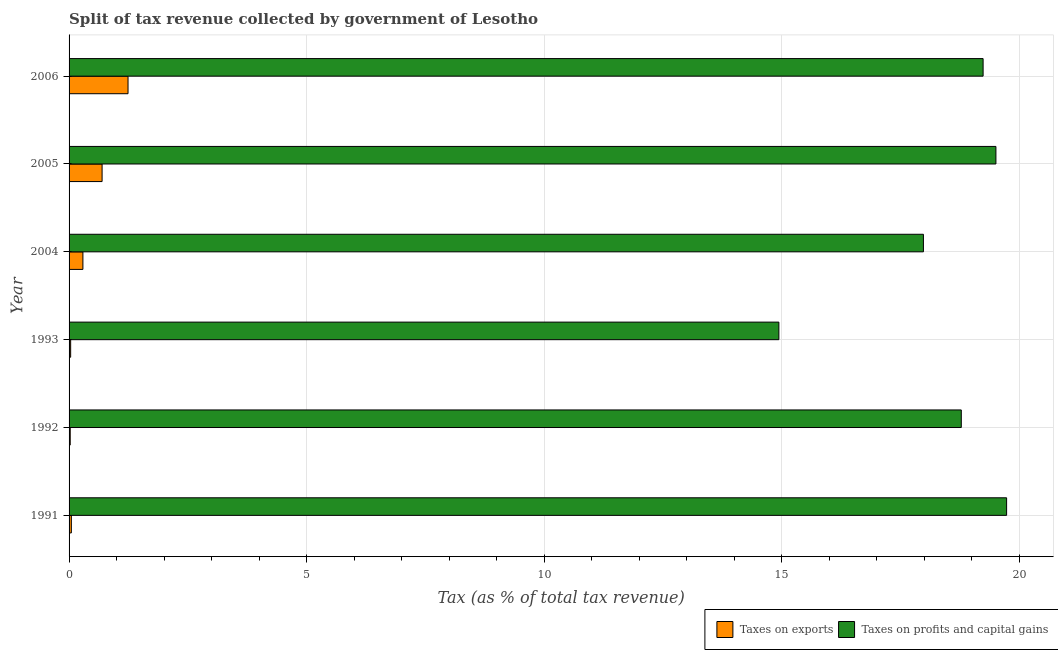How many groups of bars are there?
Make the answer very short. 6. How many bars are there on the 2nd tick from the top?
Offer a very short reply. 2. How many bars are there on the 2nd tick from the bottom?
Make the answer very short. 2. What is the label of the 4th group of bars from the top?
Provide a short and direct response. 1993. What is the percentage of revenue obtained from taxes on exports in 1991?
Give a very brief answer. 0.05. Across all years, what is the maximum percentage of revenue obtained from taxes on exports?
Ensure brevity in your answer.  1.24. Across all years, what is the minimum percentage of revenue obtained from taxes on exports?
Provide a succinct answer. 0.02. In which year was the percentage of revenue obtained from taxes on exports maximum?
Keep it short and to the point. 2006. In which year was the percentage of revenue obtained from taxes on profits and capital gains minimum?
Your answer should be very brief. 1993. What is the total percentage of revenue obtained from taxes on profits and capital gains in the graph?
Your response must be concise. 110.2. What is the difference between the percentage of revenue obtained from taxes on profits and capital gains in 1991 and that in 2005?
Provide a short and direct response. 0.23. What is the difference between the percentage of revenue obtained from taxes on exports in 2006 and the percentage of revenue obtained from taxes on profits and capital gains in 2005?
Make the answer very short. -18.27. What is the average percentage of revenue obtained from taxes on exports per year?
Offer a terse response. 0.39. In the year 2004, what is the difference between the percentage of revenue obtained from taxes on profits and capital gains and percentage of revenue obtained from taxes on exports?
Offer a terse response. 17.69. In how many years, is the percentage of revenue obtained from taxes on profits and capital gains greater than 11 %?
Your answer should be very brief. 6. What is the ratio of the percentage of revenue obtained from taxes on exports in 1993 to that in 2006?
Give a very brief answer. 0.03. Is the difference between the percentage of revenue obtained from taxes on profits and capital gains in 2005 and 2006 greater than the difference between the percentage of revenue obtained from taxes on exports in 2005 and 2006?
Offer a very short reply. Yes. What is the difference between the highest and the second highest percentage of revenue obtained from taxes on exports?
Ensure brevity in your answer.  0.55. What is the difference between the highest and the lowest percentage of revenue obtained from taxes on exports?
Offer a very short reply. 1.22. In how many years, is the percentage of revenue obtained from taxes on profits and capital gains greater than the average percentage of revenue obtained from taxes on profits and capital gains taken over all years?
Your answer should be compact. 4. What does the 2nd bar from the top in 1993 represents?
Provide a short and direct response. Taxes on exports. What does the 1st bar from the bottom in 1993 represents?
Your answer should be compact. Taxes on exports. How many years are there in the graph?
Keep it short and to the point. 6. Are the values on the major ticks of X-axis written in scientific E-notation?
Give a very brief answer. No. Does the graph contain grids?
Offer a very short reply. Yes. Where does the legend appear in the graph?
Offer a terse response. Bottom right. How many legend labels are there?
Provide a short and direct response. 2. How are the legend labels stacked?
Offer a very short reply. Horizontal. What is the title of the graph?
Provide a short and direct response. Split of tax revenue collected by government of Lesotho. What is the label or title of the X-axis?
Provide a succinct answer. Tax (as % of total tax revenue). What is the Tax (as % of total tax revenue) in Taxes on exports in 1991?
Offer a terse response. 0.05. What is the Tax (as % of total tax revenue) of Taxes on profits and capital gains in 1991?
Offer a terse response. 19.74. What is the Tax (as % of total tax revenue) in Taxes on exports in 1992?
Keep it short and to the point. 0.02. What is the Tax (as % of total tax revenue) in Taxes on profits and capital gains in 1992?
Your answer should be compact. 18.78. What is the Tax (as % of total tax revenue) of Taxes on exports in 1993?
Offer a very short reply. 0.03. What is the Tax (as % of total tax revenue) of Taxes on profits and capital gains in 1993?
Keep it short and to the point. 14.94. What is the Tax (as % of total tax revenue) of Taxes on exports in 2004?
Your response must be concise. 0.29. What is the Tax (as % of total tax revenue) in Taxes on profits and capital gains in 2004?
Give a very brief answer. 17.99. What is the Tax (as % of total tax revenue) of Taxes on exports in 2005?
Your response must be concise. 0.7. What is the Tax (as % of total tax revenue) of Taxes on profits and capital gains in 2005?
Your answer should be compact. 19.51. What is the Tax (as % of total tax revenue) in Taxes on exports in 2006?
Your response must be concise. 1.24. What is the Tax (as % of total tax revenue) of Taxes on profits and capital gains in 2006?
Offer a terse response. 19.24. Across all years, what is the maximum Tax (as % of total tax revenue) in Taxes on exports?
Offer a very short reply. 1.24. Across all years, what is the maximum Tax (as % of total tax revenue) in Taxes on profits and capital gains?
Offer a terse response. 19.74. Across all years, what is the minimum Tax (as % of total tax revenue) in Taxes on exports?
Your answer should be compact. 0.02. Across all years, what is the minimum Tax (as % of total tax revenue) of Taxes on profits and capital gains?
Give a very brief answer. 14.94. What is the total Tax (as % of total tax revenue) of Taxes on exports in the graph?
Offer a terse response. 2.33. What is the total Tax (as % of total tax revenue) in Taxes on profits and capital gains in the graph?
Your answer should be very brief. 110.2. What is the difference between the Tax (as % of total tax revenue) of Taxes on exports in 1991 and that in 1992?
Provide a short and direct response. 0.02. What is the difference between the Tax (as % of total tax revenue) of Taxes on profits and capital gains in 1991 and that in 1992?
Give a very brief answer. 0.95. What is the difference between the Tax (as % of total tax revenue) in Taxes on exports in 1991 and that in 1993?
Offer a terse response. 0.01. What is the difference between the Tax (as % of total tax revenue) of Taxes on profits and capital gains in 1991 and that in 1993?
Keep it short and to the point. 4.79. What is the difference between the Tax (as % of total tax revenue) of Taxes on exports in 1991 and that in 2004?
Keep it short and to the point. -0.24. What is the difference between the Tax (as % of total tax revenue) of Taxes on profits and capital gains in 1991 and that in 2004?
Make the answer very short. 1.75. What is the difference between the Tax (as % of total tax revenue) in Taxes on exports in 1991 and that in 2005?
Your response must be concise. -0.65. What is the difference between the Tax (as % of total tax revenue) in Taxes on profits and capital gains in 1991 and that in 2005?
Your answer should be compact. 0.23. What is the difference between the Tax (as % of total tax revenue) in Taxes on exports in 1991 and that in 2006?
Make the answer very short. -1.19. What is the difference between the Tax (as % of total tax revenue) of Taxes on profits and capital gains in 1991 and that in 2006?
Give a very brief answer. 0.49. What is the difference between the Tax (as % of total tax revenue) of Taxes on exports in 1992 and that in 1993?
Provide a succinct answer. -0.01. What is the difference between the Tax (as % of total tax revenue) in Taxes on profits and capital gains in 1992 and that in 1993?
Your answer should be very brief. 3.84. What is the difference between the Tax (as % of total tax revenue) of Taxes on exports in 1992 and that in 2004?
Keep it short and to the point. -0.27. What is the difference between the Tax (as % of total tax revenue) of Taxes on profits and capital gains in 1992 and that in 2004?
Give a very brief answer. 0.8. What is the difference between the Tax (as % of total tax revenue) of Taxes on exports in 1992 and that in 2005?
Offer a terse response. -0.67. What is the difference between the Tax (as % of total tax revenue) of Taxes on profits and capital gains in 1992 and that in 2005?
Make the answer very short. -0.73. What is the difference between the Tax (as % of total tax revenue) in Taxes on exports in 1992 and that in 2006?
Offer a very short reply. -1.22. What is the difference between the Tax (as % of total tax revenue) in Taxes on profits and capital gains in 1992 and that in 2006?
Provide a succinct answer. -0.46. What is the difference between the Tax (as % of total tax revenue) of Taxes on exports in 1993 and that in 2004?
Offer a terse response. -0.26. What is the difference between the Tax (as % of total tax revenue) in Taxes on profits and capital gains in 1993 and that in 2004?
Make the answer very short. -3.04. What is the difference between the Tax (as % of total tax revenue) in Taxes on exports in 1993 and that in 2005?
Offer a very short reply. -0.66. What is the difference between the Tax (as % of total tax revenue) of Taxes on profits and capital gains in 1993 and that in 2005?
Keep it short and to the point. -4.57. What is the difference between the Tax (as % of total tax revenue) of Taxes on exports in 1993 and that in 2006?
Offer a very short reply. -1.21. What is the difference between the Tax (as % of total tax revenue) in Taxes on profits and capital gains in 1993 and that in 2006?
Give a very brief answer. -4.3. What is the difference between the Tax (as % of total tax revenue) of Taxes on exports in 2004 and that in 2005?
Make the answer very short. -0.4. What is the difference between the Tax (as % of total tax revenue) of Taxes on profits and capital gains in 2004 and that in 2005?
Offer a very short reply. -1.53. What is the difference between the Tax (as % of total tax revenue) of Taxes on exports in 2004 and that in 2006?
Your answer should be compact. -0.95. What is the difference between the Tax (as % of total tax revenue) of Taxes on profits and capital gains in 2004 and that in 2006?
Offer a terse response. -1.26. What is the difference between the Tax (as % of total tax revenue) of Taxes on exports in 2005 and that in 2006?
Provide a short and direct response. -0.55. What is the difference between the Tax (as % of total tax revenue) in Taxes on profits and capital gains in 2005 and that in 2006?
Ensure brevity in your answer.  0.27. What is the difference between the Tax (as % of total tax revenue) in Taxes on exports in 1991 and the Tax (as % of total tax revenue) in Taxes on profits and capital gains in 1992?
Offer a terse response. -18.73. What is the difference between the Tax (as % of total tax revenue) of Taxes on exports in 1991 and the Tax (as % of total tax revenue) of Taxes on profits and capital gains in 1993?
Give a very brief answer. -14.89. What is the difference between the Tax (as % of total tax revenue) in Taxes on exports in 1991 and the Tax (as % of total tax revenue) in Taxes on profits and capital gains in 2004?
Make the answer very short. -17.94. What is the difference between the Tax (as % of total tax revenue) in Taxes on exports in 1991 and the Tax (as % of total tax revenue) in Taxes on profits and capital gains in 2005?
Make the answer very short. -19.46. What is the difference between the Tax (as % of total tax revenue) in Taxes on exports in 1991 and the Tax (as % of total tax revenue) in Taxes on profits and capital gains in 2006?
Offer a terse response. -19.19. What is the difference between the Tax (as % of total tax revenue) of Taxes on exports in 1992 and the Tax (as % of total tax revenue) of Taxes on profits and capital gains in 1993?
Provide a short and direct response. -14.92. What is the difference between the Tax (as % of total tax revenue) in Taxes on exports in 1992 and the Tax (as % of total tax revenue) in Taxes on profits and capital gains in 2004?
Provide a succinct answer. -17.96. What is the difference between the Tax (as % of total tax revenue) in Taxes on exports in 1992 and the Tax (as % of total tax revenue) in Taxes on profits and capital gains in 2005?
Your response must be concise. -19.49. What is the difference between the Tax (as % of total tax revenue) in Taxes on exports in 1992 and the Tax (as % of total tax revenue) in Taxes on profits and capital gains in 2006?
Your response must be concise. -19.22. What is the difference between the Tax (as % of total tax revenue) of Taxes on exports in 1993 and the Tax (as % of total tax revenue) of Taxes on profits and capital gains in 2004?
Your answer should be compact. -17.95. What is the difference between the Tax (as % of total tax revenue) of Taxes on exports in 1993 and the Tax (as % of total tax revenue) of Taxes on profits and capital gains in 2005?
Make the answer very short. -19.48. What is the difference between the Tax (as % of total tax revenue) in Taxes on exports in 1993 and the Tax (as % of total tax revenue) in Taxes on profits and capital gains in 2006?
Offer a terse response. -19.21. What is the difference between the Tax (as % of total tax revenue) in Taxes on exports in 2004 and the Tax (as % of total tax revenue) in Taxes on profits and capital gains in 2005?
Offer a terse response. -19.22. What is the difference between the Tax (as % of total tax revenue) in Taxes on exports in 2004 and the Tax (as % of total tax revenue) in Taxes on profits and capital gains in 2006?
Give a very brief answer. -18.95. What is the difference between the Tax (as % of total tax revenue) in Taxes on exports in 2005 and the Tax (as % of total tax revenue) in Taxes on profits and capital gains in 2006?
Your answer should be compact. -18.55. What is the average Tax (as % of total tax revenue) in Taxes on exports per year?
Make the answer very short. 0.39. What is the average Tax (as % of total tax revenue) of Taxes on profits and capital gains per year?
Provide a succinct answer. 18.37. In the year 1991, what is the difference between the Tax (as % of total tax revenue) of Taxes on exports and Tax (as % of total tax revenue) of Taxes on profits and capital gains?
Ensure brevity in your answer.  -19.69. In the year 1992, what is the difference between the Tax (as % of total tax revenue) of Taxes on exports and Tax (as % of total tax revenue) of Taxes on profits and capital gains?
Provide a short and direct response. -18.76. In the year 1993, what is the difference between the Tax (as % of total tax revenue) in Taxes on exports and Tax (as % of total tax revenue) in Taxes on profits and capital gains?
Give a very brief answer. -14.91. In the year 2004, what is the difference between the Tax (as % of total tax revenue) in Taxes on exports and Tax (as % of total tax revenue) in Taxes on profits and capital gains?
Offer a terse response. -17.69. In the year 2005, what is the difference between the Tax (as % of total tax revenue) in Taxes on exports and Tax (as % of total tax revenue) in Taxes on profits and capital gains?
Offer a terse response. -18.82. In the year 2006, what is the difference between the Tax (as % of total tax revenue) of Taxes on exports and Tax (as % of total tax revenue) of Taxes on profits and capital gains?
Ensure brevity in your answer.  -18. What is the ratio of the Tax (as % of total tax revenue) of Taxes on exports in 1991 to that in 1992?
Ensure brevity in your answer.  1.97. What is the ratio of the Tax (as % of total tax revenue) of Taxes on profits and capital gains in 1991 to that in 1992?
Offer a terse response. 1.05. What is the ratio of the Tax (as % of total tax revenue) in Taxes on exports in 1991 to that in 1993?
Keep it short and to the point. 1.44. What is the ratio of the Tax (as % of total tax revenue) of Taxes on profits and capital gains in 1991 to that in 1993?
Your answer should be very brief. 1.32. What is the ratio of the Tax (as % of total tax revenue) of Taxes on exports in 1991 to that in 2004?
Offer a very short reply. 0.16. What is the ratio of the Tax (as % of total tax revenue) in Taxes on profits and capital gains in 1991 to that in 2004?
Offer a terse response. 1.1. What is the ratio of the Tax (as % of total tax revenue) in Taxes on exports in 1991 to that in 2005?
Provide a succinct answer. 0.07. What is the ratio of the Tax (as % of total tax revenue) of Taxes on profits and capital gains in 1991 to that in 2005?
Provide a short and direct response. 1.01. What is the ratio of the Tax (as % of total tax revenue) of Taxes on exports in 1991 to that in 2006?
Offer a terse response. 0.04. What is the ratio of the Tax (as % of total tax revenue) in Taxes on profits and capital gains in 1991 to that in 2006?
Your answer should be compact. 1.03. What is the ratio of the Tax (as % of total tax revenue) of Taxes on exports in 1992 to that in 1993?
Offer a very short reply. 0.73. What is the ratio of the Tax (as % of total tax revenue) in Taxes on profits and capital gains in 1992 to that in 1993?
Ensure brevity in your answer.  1.26. What is the ratio of the Tax (as % of total tax revenue) in Taxes on exports in 1992 to that in 2004?
Offer a terse response. 0.08. What is the ratio of the Tax (as % of total tax revenue) in Taxes on profits and capital gains in 1992 to that in 2004?
Your answer should be compact. 1.04. What is the ratio of the Tax (as % of total tax revenue) of Taxes on exports in 1992 to that in 2005?
Make the answer very short. 0.03. What is the ratio of the Tax (as % of total tax revenue) in Taxes on profits and capital gains in 1992 to that in 2005?
Offer a terse response. 0.96. What is the ratio of the Tax (as % of total tax revenue) of Taxes on exports in 1992 to that in 2006?
Offer a terse response. 0.02. What is the ratio of the Tax (as % of total tax revenue) in Taxes on profits and capital gains in 1992 to that in 2006?
Give a very brief answer. 0.98. What is the ratio of the Tax (as % of total tax revenue) of Taxes on exports in 1993 to that in 2004?
Provide a short and direct response. 0.11. What is the ratio of the Tax (as % of total tax revenue) of Taxes on profits and capital gains in 1993 to that in 2004?
Your answer should be very brief. 0.83. What is the ratio of the Tax (as % of total tax revenue) of Taxes on exports in 1993 to that in 2005?
Offer a very short reply. 0.05. What is the ratio of the Tax (as % of total tax revenue) of Taxes on profits and capital gains in 1993 to that in 2005?
Your answer should be very brief. 0.77. What is the ratio of the Tax (as % of total tax revenue) in Taxes on exports in 1993 to that in 2006?
Offer a very short reply. 0.03. What is the ratio of the Tax (as % of total tax revenue) in Taxes on profits and capital gains in 1993 to that in 2006?
Provide a short and direct response. 0.78. What is the ratio of the Tax (as % of total tax revenue) in Taxes on exports in 2004 to that in 2005?
Provide a succinct answer. 0.42. What is the ratio of the Tax (as % of total tax revenue) in Taxes on profits and capital gains in 2004 to that in 2005?
Offer a terse response. 0.92. What is the ratio of the Tax (as % of total tax revenue) in Taxes on exports in 2004 to that in 2006?
Provide a succinct answer. 0.23. What is the ratio of the Tax (as % of total tax revenue) of Taxes on profits and capital gains in 2004 to that in 2006?
Provide a succinct answer. 0.93. What is the ratio of the Tax (as % of total tax revenue) in Taxes on exports in 2005 to that in 2006?
Ensure brevity in your answer.  0.56. What is the difference between the highest and the second highest Tax (as % of total tax revenue) of Taxes on exports?
Keep it short and to the point. 0.55. What is the difference between the highest and the second highest Tax (as % of total tax revenue) of Taxes on profits and capital gains?
Your answer should be compact. 0.23. What is the difference between the highest and the lowest Tax (as % of total tax revenue) in Taxes on exports?
Provide a succinct answer. 1.22. What is the difference between the highest and the lowest Tax (as % of total tax revenue) in Taxes on profits and capital gains?
Your response must be concise. 4.79. 